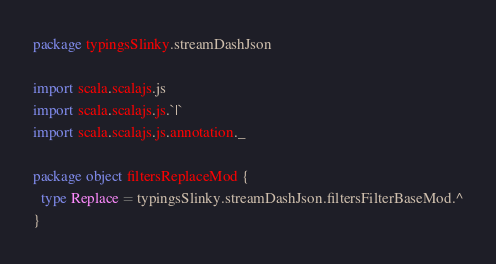<code> <loc_0><loc_0><loc_500><loc_500><_Scala_>package typingsSlinky.streamDashJson

import scala.scalajs.js
import scala.scalajs.js.`|`
import scala.scalajs.js.annotation._

package object filtersReplaceMod {
  type Replace = typingsSlinky.streamDashJson.filtersFilterBaseMod.^
}
</code> 